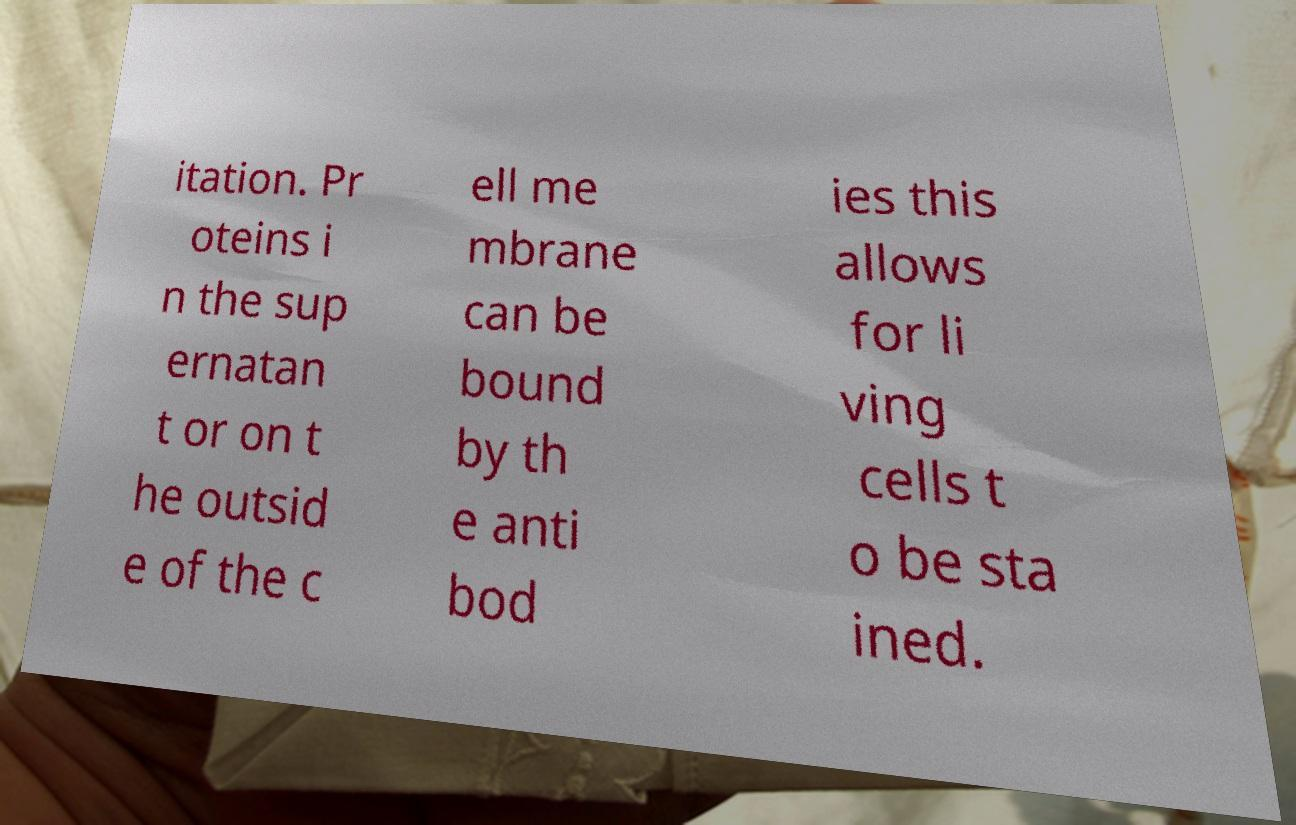Could you extract and type out the text from this image? itation. Pr oteins i n the sup ernatan t or on t he outsid e of the c ell me mbrane can be bound by th e anti bod ies this allows for li ving cells t o be sta ined. 